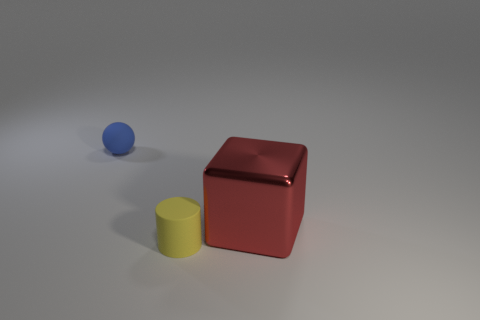Add 3 large cyan things. How many objects exist? 6 Subtract 0 green spheres. How many objects are left? 3 Subtract all cylinders. How many objects are left? 2 Subtract all purple blocks. Subtract all red cylinders. How many blocks are left? 1 Subtract all blue cylinders. How many gray blocks are left? 0 Subtract all tiny purple matte balls. Subtract all red things. How many objects are left? 2 Add 3 big red things. How many big red things are left? 4 Add 2 blue matte blocks. How many blue matte blocks exist? 2 